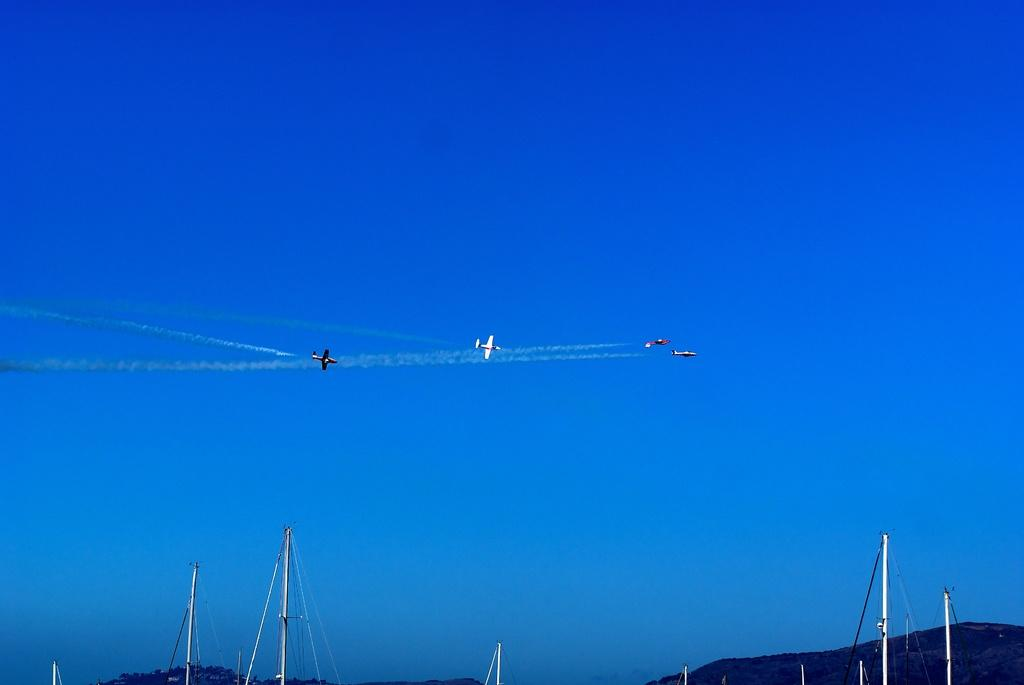How many airplanes can be seen in the image? There are four airplanes flying in the air in the image. What else can be seen in the image besides the airplanes? There are poles visible in the image, as well as a hill. What is visible in the background of the image? The sky is visible in the background of the image. What type of rod can be seen on the sidewalk in the image? There is no sidewalk or rod present in the image; it features airplanes, poles, and a hill. 